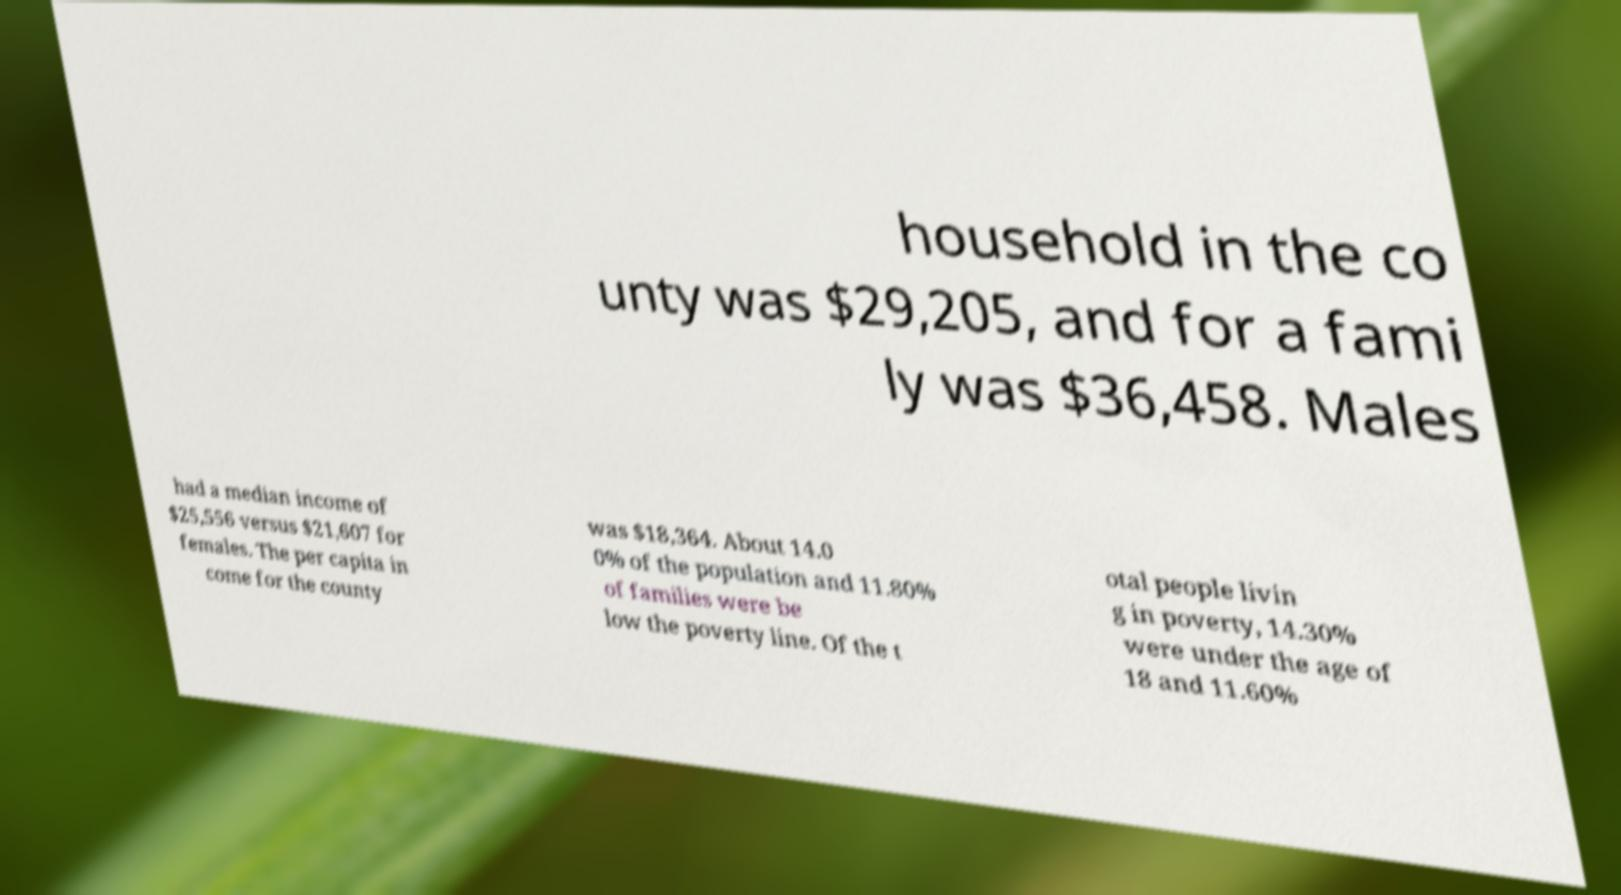For documentation purposes, I need the text within this image transcribed. Could you provide that? household in the co unty was $29,205, and for a fami ly was $36,458. Males had a median income of $25,556 versus $21,607 for females. The per capita in come for the county was $18,364. About 14.0 0% of the population and 11.80% of families were be low the poverty line. Of the t otal people livin g in poverty, 14.30% were under the age of 18 and 11.60% 